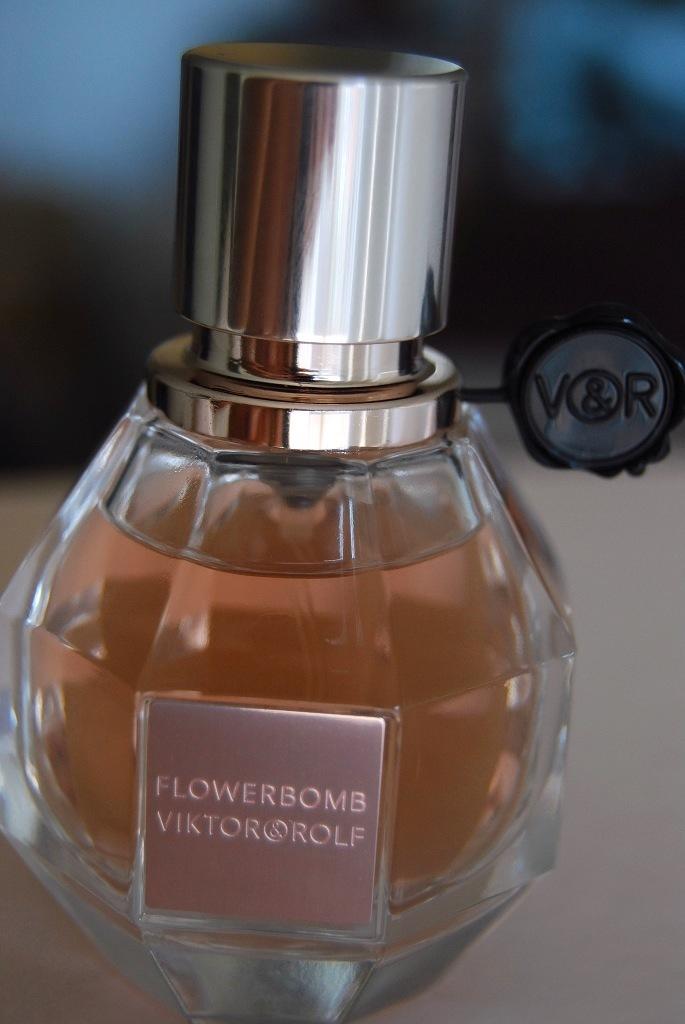What is the flower-related title of this perfume?
Ensure brevity in your answer.  Flowerbomb. Who makes this perfume?
Offer a very short reply. Viktor rolf. 